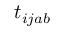<formula> <loc_0><loc_0><loc_500><loc_500>t _ { i j a b }</formula> 